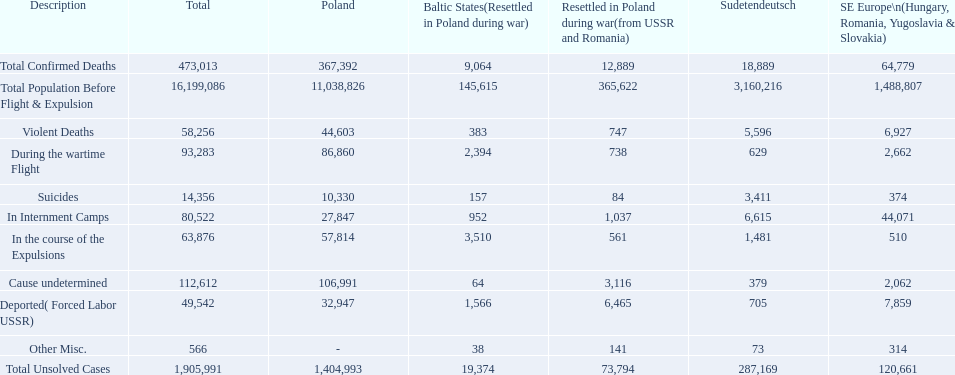What were all of the types of deaths? Violent Deaths, Suicides, Deported( Forced Labor USSR), In Internment Camps, During the wartime Flight, In the course of the Expulsions, Cause undetermined, Other Misc. And their totals in the baltic states? 383, 157, 1,566, 952, 2,394, 3,510, 64, 38. Were more deaths in the baltic states caused by undetermined causes or misc.? Cause undetermined. 